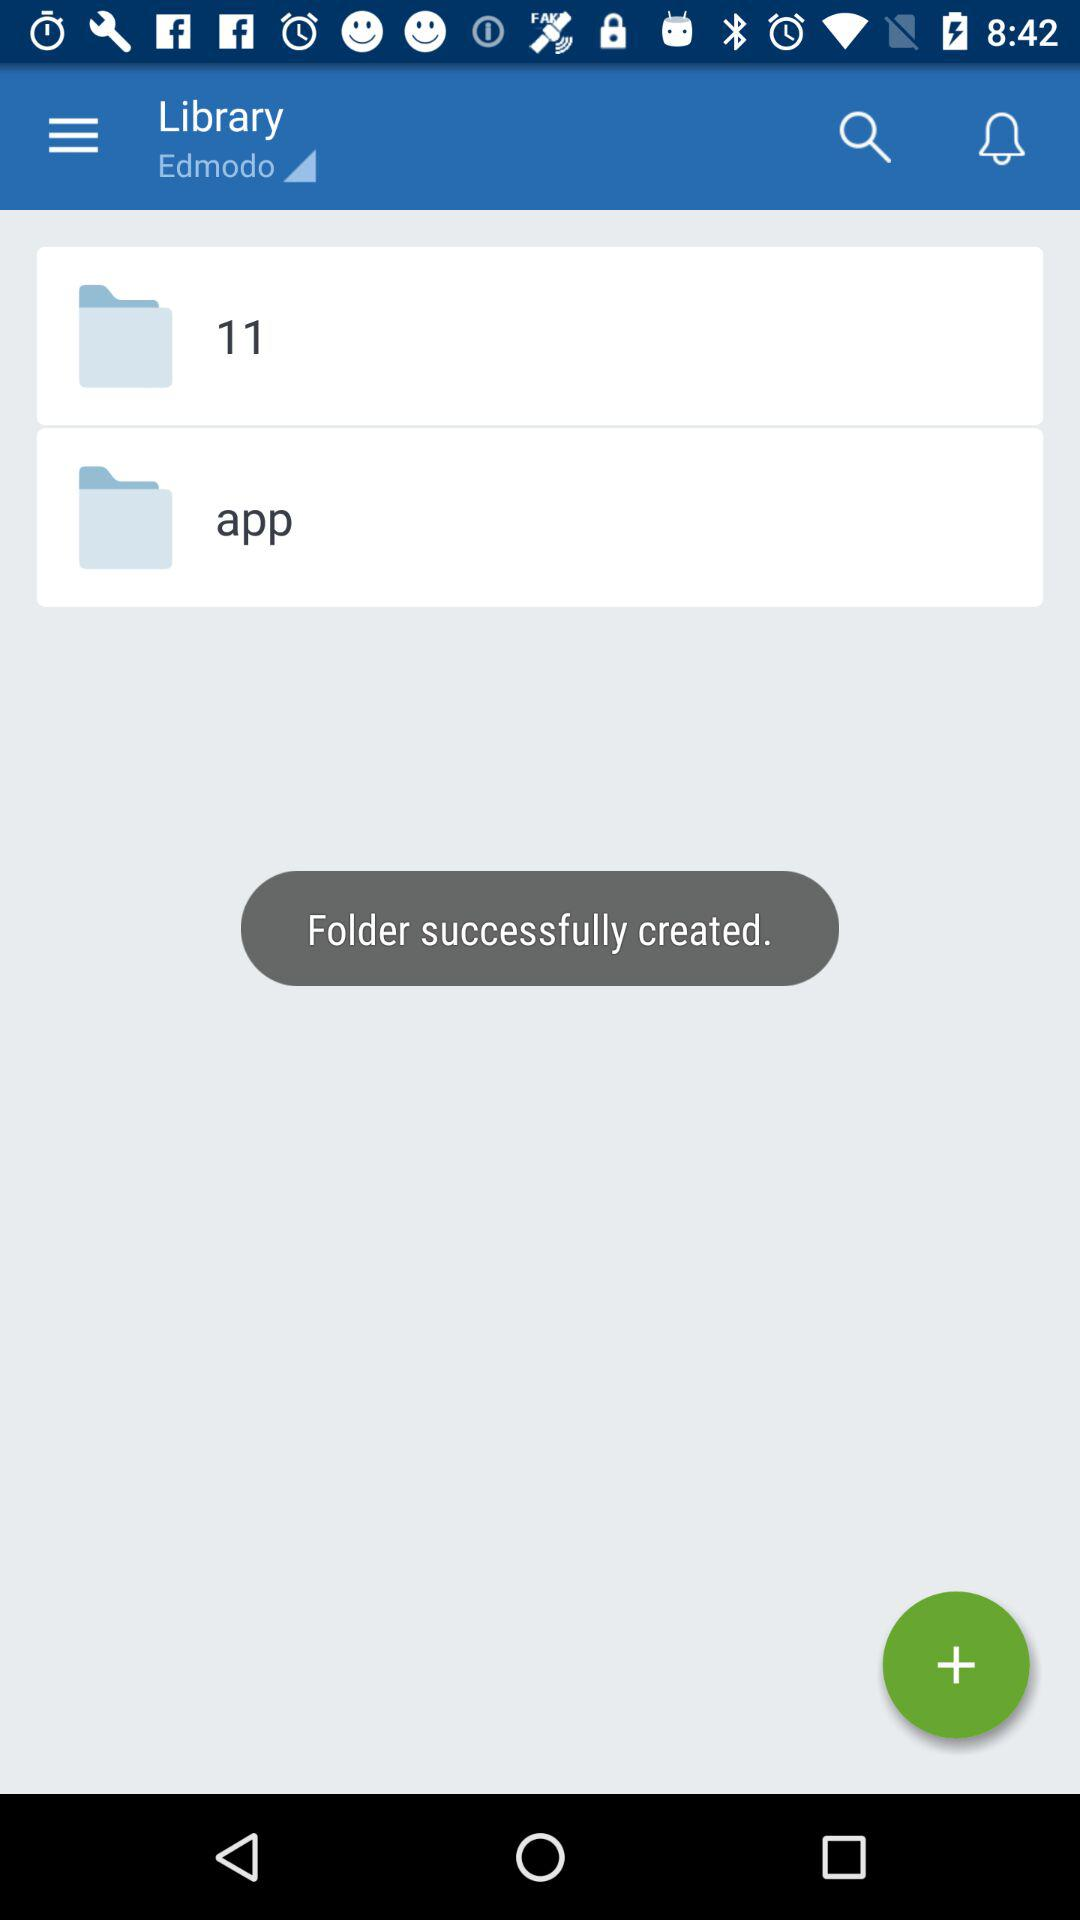What are the names of the folders? The names of the folders are 11 and app. 